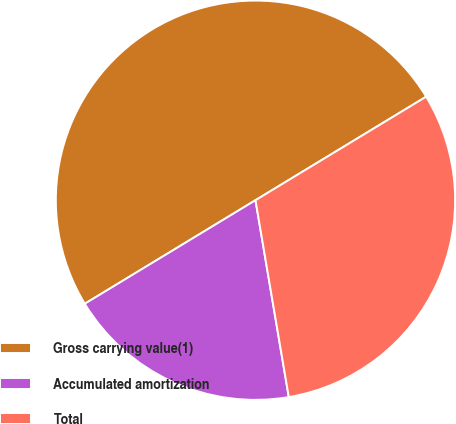Convert chart to OTSL. <chart><loc_0><loc_0><loc_500><loc_500><pie_chart><fcel>Gross carrying value(1)<fcel>Accumulated amortization<fcel>Total<nl><fcel>50.0%<fcel>18.99%<fcel>31.01%<nl></chart> 